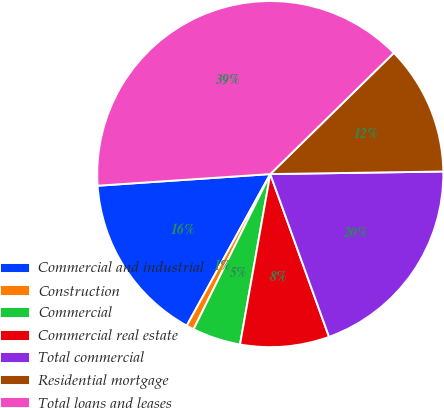Convert chart. <chart><loc_0><loc_0><loc_500><loc_500><pie_chart><fcel>Commercial and industrial<fcel>Construction<fcel>Commercial<fcel>Commercial real estate<fcel>Total commercial<fcel>Residential mortgage<fcel>Total loans and leases<nl><fcel>15.91%<fcel>0.71%<fcel>4.51%<fcel>8.31%<fcel>19.72%<fcel>12.11%<fcel>38.72%<nl></chart> 